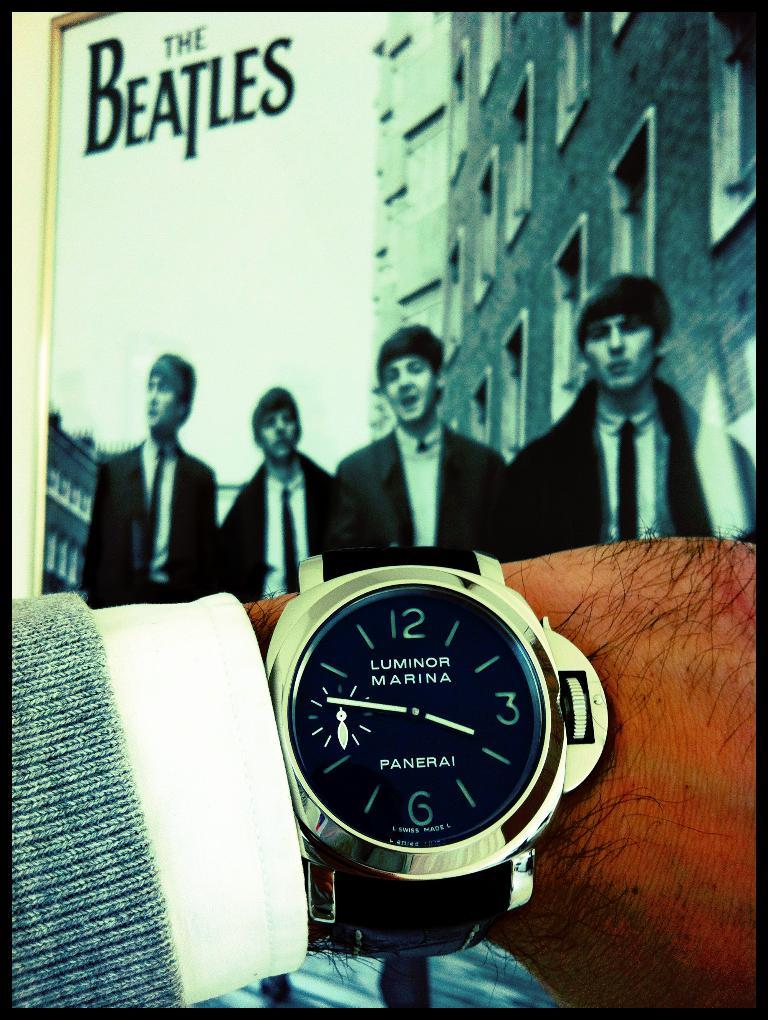Provide a one-sentence caption for the provided image. A poster of the Beatles can be seen in front of a mans wrist, who is wearing a Panerai Luminor wrist watch. 